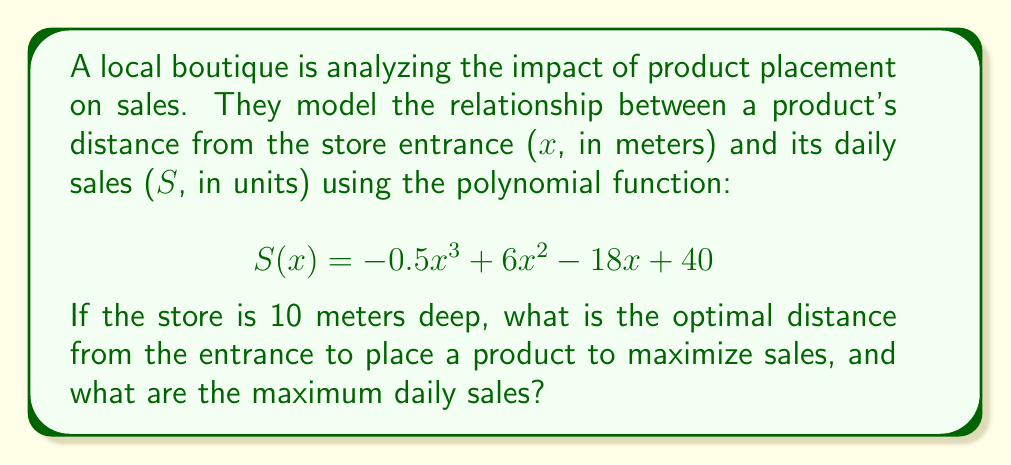Give your solution to this math problem. To find the optimal distance and maximum sales, we need to follow these steps:

1. Find the derivative of the sales function:
   $S'(x) = -1.5x^2 + 12x - 18$

2. Set the derivative equal to zero to find critical points:
   $-1.5x^2 + 12x - 18 = 0$

3. Solve the quadratic equation:
   $-1.5(x^2 - 8x + 12) = 0$
   $x^2 - 8x + 12 = 0$
   $(x - 6)(x - 2) = 0$
   $x = 6$ or $x = 2$

4. Check the endpoints (0 and 10) and critical points:
   $S(0) = 40$
   $S(2) = -0.5(2^3) + 6(2^2) - 18(2) + 40 = -4 + 24 - 36 + 40 = 24$
   $S(6) = -0.5(6^3) + 6(6^2) - 18(6) + 40 = -108 + 216 - 108 + 40 = 40$
   $S(10) = -0.5(10^3) + 6(10^2) - 18(10) + 40 = -500 + 600 - 180 + 40 = -40$

5. The maximum value occurs at x = 2 meters from the entrance.

6. The maximum daily sales are $S(2) = 24$ units.
Answer: 2 meters; 24 units 